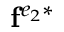<formula> <loc_0><loc_0><loc_500><loc_500>f ^ { e _ { 2 } * }</formula> 